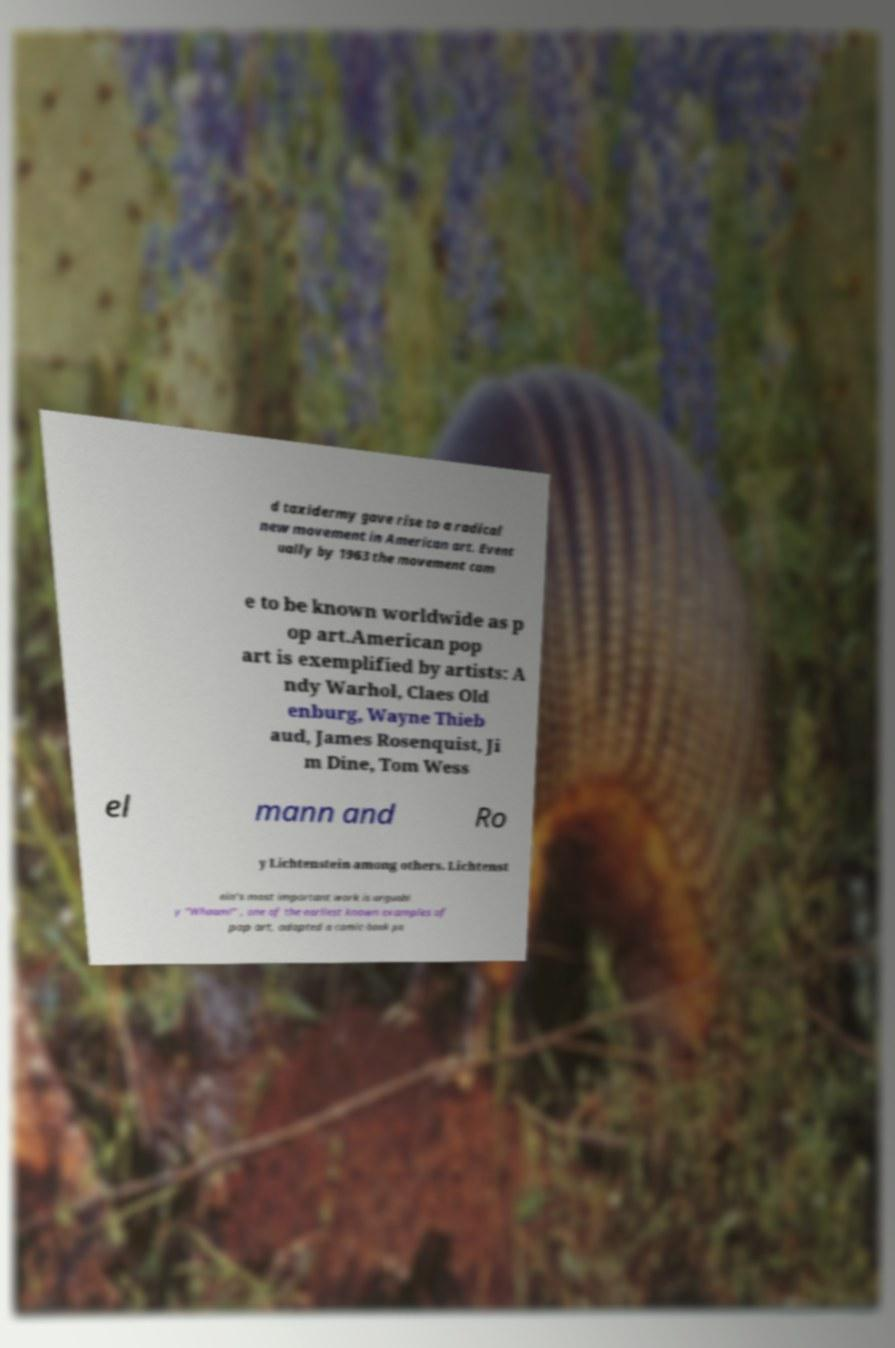There's text embedded in this image that I need extracted. Can you transcribe it verbatim? d taxidermy gave rise to a radical new movement in American art. Event ually by 1963 the movement cam e to be known worldwide as p op art.American pop art is exemplified by artists: A ndy Warhol, Claes Old enburg, Wayne Thieb aud, James Rosenquist, Ji m Dine, Tom Wess el mann and Ro y Lichtenstein among others. Lichtenst ein's most important work is arguabl y "Whaam!" , one of the earliest known examples of pop art, adapted a comic-book pa 